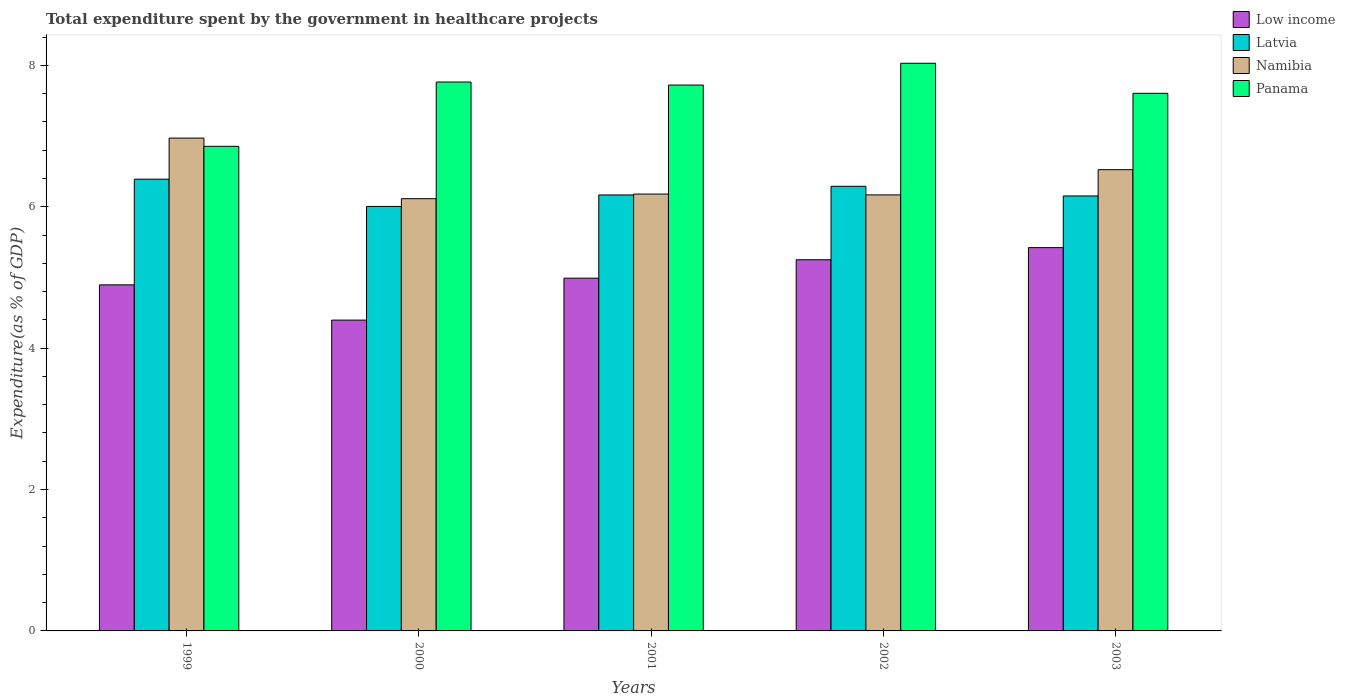How many different coloured bars are there?
Ensure brevity in your answer.  4. How many groups of bars are there?
Give a very brief answer. 5. Are the number of bars per tick equal to the number of legend labels?
Your answer should be very brief. Yes. Are the number of bars on each tick of the X-axis equal?
Your response must be concise. Yes. How many bars are there on the 2nd tick from the right?
Offer a terse response. 4. In how many cases, is the number of bars for a given year not equal to the number of legend labels?
Your answer should be compact. 0. What is the total expenditure spent by the government in healthcare projects in Namibia in 1999?
Provide a short and direct response. 6.97. Across all years, what is the maximum total expenditure spent by the government in healthcare projects in Low income?
Your answer should be compact. 5.42. Across all years, what is the minimum total expenditure spent by the government in healthcare projects in Low income?
Offer a terse response. 4.4. In which year was the total expenditure spent by the government in healthcare projects in Namibia minimum?
Offer a very short reply. 2000. What is the total total expenditure spent by the government in healthcare projects in Panama in the graph?
Provide a short and direct response. 37.97. What is the difference between the total expenditure spent by the government in healthcare projects in Low income in 1999 and that in 2000?
Give a very brief answer. 0.5. What is the difference between the total expenditure spent by the government in healthcare projects in Panama in 2003 and the total expenditure spent by the government in healthcare projects in Namibia in 2002?
Ensure brevity in your answer.  1.44. What is the average total expenditure spent by the government in healthcare projects in Latvia per year?
Provide a succinct answer. 6.2. In the year 2002, what is the difference between the total expenditure spent by the government in healthcare projects in Panama and total expenditure spent by the government in healthcare projects in Namibia?
Make the answer very short. 1.86. What is the ratio of the total expenditure spent by the government in healthcare projects in Namibia in 2000 to that in 2001?
Your answer should be very brief. 0.99. What is the difference between the highest and the second highest total expenditure spent by the government in healthcare projects in Namibia?
Your answer should be compact. 0.45. What is the difference between the highest and the lowest total expenditure spent by the government in healthcare projects in Low income?
Provide a succinct answer. 1.02. In how many years, is the total expenditure spent by the government in healthcare projects in Namibia greater than the average total expenditure spent by the government in healthcare projects in Namibia taken over all years?
Your response must be concise. 2. Is the sum of the total expenditure spent by the government in healthcare projects in Panama in 2000 and 2001 greater than the maximum total expenditure spent by the government in healthcare projects in Namibia across all years?
Offer a terse response. Yes. Is it the case that in every year, the sum of the total expenditure spent by the government in healthcare projects in Panama and total expenditure spent by the government in healthcare projects in Latvia is greater than the sum of total expenditure spent by the government in healthcare projects in Low income and total expenditure spent by the government in healthcare projects in Namibia?
Offer a terse response. No. What does the 2nd bar from the left in 2000 represents?
Keep it short and to the point. Latvia. What does the 3rd bar from the right in 2003 represents?
Keep it short and to the point. Latvia. How many bars are there?
Make the answer very short. 20. How many years are there in the graph?
Ensure brevity in your answer.  5. What is the difference between two consecutive major ticks on the Y-axis?
Your response must be concise. 2. Does the graph contain any zero values?
Your answer should be compact. No. How many legend labels are there?
Ensure brevity in your answer.  4. How are the legend labels stacked?
Keep it short and to the point. Vertical. What is the title of the graph?
Provide a short and direct response. Total expenditure spent by the government in healthcare projects. Does "Tonga" appear as one of the legend labels in the graph?
Provide a succinct answer. No. What is the label or title of the Y-axis?
Provide a short and direct response. Expenditure(as % of GDP). What is the Expenditure(as % of GDP) of Low income in 1999?
Ensure brevity in your answer.  4.89. What is the Expenditure(as % of GDP) in Latvia in 1999?
Provide a short and direct response. 6.39. What is the Expenditure(as % of GDP) in Namibia in 1999?
Your answer should be very brief. 6.97. What is the Expenditure(as % of GDP) of Panama in 1999?
Your response must be concise. 6.85. What is the Expenditure(as % of GDP) of Low income in 2000?
Keep it short and to the point. 4.4. What is the Expenditure(as % of GDP) of Latvia in 2000?
Provide a succinct answer. 6. What is the Expenditure(as % of GDP) of Namibia in 2000?
Make the answer very short. 6.11. What is the Expenditure(as % of GDP) in Panama in 2000?
Make the answer very short. 7.76. What is the Expenditure(as % of GDP) in Low income in 2001?
Provide a short and direct response. 4.99. What is the Expenditure(as % of GDP) in Latvia in 2001?
Offer a terse response. 6.17. What is the Expenditure(as % of GDP) in Namibia in 2001?
Your answer should be compact. 6.18. What is the Expenditure(as % of GDP) in Panama in 2001?
Provide a short and direct response. 7.72. What is the Expenditure(as % of GDP) of Low income in 2002?
Ensure brevity in your answer.  5.25. What is the Expenditure(as % of GDP) in Latvia in 2002?
Keep it short and to the point. 6.29. What is the Expenditure(as % of GDP) of Namibia in 2002?
Provide a short and direct response. 6.17. What is the Expenditure(as % of GDP) in Panama in 2002?
Provide a succinct answer. 8.03. What is the Expenditure(as % of GDP) of Low income in 2003?
Offer a very short reply. 5.42. What is the Expenditure(as % of GDP) in Latvia in 2003?
Provide a short and direct response. 6.15. What is the Expenditure(as % of GDP) in Namibia in 2003?
Give a very brief answer. 6.52. What is the Expenditure(as % of GDP) of Panama in 2003?
Give a very brief answer. 7.6. Across all years, what is the maximum Expenditure(as % of GDP) in Low income?
Give a very brief answer. 5.42. Across all years, what is the maximum Expenditure(as % of GDP) of Latvia?
Your answer should be compact. 6.39. Across all years, what is the maximum Expenditure(as % of GDP) of Namibia?
Ensure brevity in your answer.  6.97. Across all years, what is the maximum Expenditure(as % of GDP) of Panama?
Offer a very short reply. 8.03. Across all years, what is the minimum Expenditure(as % of GDP) of Low income?
Keep it short and to the point. 4.4. Across all years, what is the minimum Expenditure(as % of GDP) of Latvia?
Ensure brevity in your answer.  6. Across all years, what is the minimum Expenditure(as % of GDP) of Namibia?
Make the answer very short. 6.11. Across all years, what is the minimum Expenditure(as % of GDP) of Panama?
Your answer should be very brief. 6.85. What is the total Expenditure(as % of GDP) in Low income in the graph?
Provide a short and direct response. 24.95. What is the total Expenditure(as % of GDP) of Latvia in the graph?
Give a very brief answer. 31. What is the total Expenditure(as % of GDP) in Namibia in the graph?
Offer a terse response. 31.96. What is the total Expenditure(as % of GDP) of Panama in the graph?
Your answer should be compact. 37.97. What is the difference between the Expenditure(as % of GDP) in Low income in 1999 and that in 2000?
Offer a terse response. 0.5. What is the difference between the Expenditure(as % of GDP) in Latvia in 1999 and that in 2000?
Offer a very short reply. 0.39. What is the difference between the Expenditure(as % of GDP) of Namibia in 1999 and that in 2000?
Your answer should be very brief. 0.86. What is the difference between the Expenditure(as % of GDP) of Panama in 1999 and that in 2000?
Your answer should be very brief. -0.91. What is the difference between the Expenditure(as % of GDP) in Low income in 1999 and that in 2001?
Keep it short and to the point. -0.09. What is the difference between the Expenditure(as % of GDP) in Latvia in 1999 and that in 2001?
Offer a very short reply. 0.22. What is the difference between the Expenditure(as % of GDP) in Namibia in 1999 and that in 2001?
Ensure brevity in your answer.  0.79. What is the difference between the Expenditure(as % of GDP) in Panama in 1999 and that in 2001?
Make the answer very short. -0.87. What is the difference between the Expenditure(as % of GDP) of Low income in 1999 and that in 2002?
Your answer should be very brief. -0.36. What is the difference between the Expenditure(as % of GDP) of Latvia in 1999 and that in 2002?
Your answer should be compact. 0.1. What is the difference between the Expenditure(as % of GDP) of Namibia in 1999 and that in 2002?
Provide a short and direct response. 0.8. What is the difference between the Expenditure(as % of GDP) of Panama in 1999 and that in 2002?
Offer a terse response. -1.17. What is the difference between the Expenditure(as % of GDP) in Low income in 1999 and that in 2003?
Offer a very short reply. -0.53. What is the difference between the Expenditure(as % of GDP) of Latvia in 1999 and that in 2003?
Your response must be concise. 0.24. What is the difference between the Expenditure(as % of GDP) in Namibia in 1999 and that in 2003?
Make the answer very short. 0.45. What is the difference between the Expenditure(as % of GDP) of Panama in 1999 and that in 2003?
Keep it short and to the point. -0.75. What is the difference between the Expenditure(as % of GDP) of Low income in 2000 and that in 2001?
Your answer should be very brief. -0.59. What is the difference between the Expenditure(as % of GDP) of Latvia in 2000 and that in 2001?
Offer a terse response. -0.16. What is the difference between the Expenditure(as % of GDP) of Namibia in 2000 and that in 2001?
Make the answer very short. -0.07. What is the difference between the Expenditure(as % of GDP) in Panama in 2000 and that in 2001?
Give a very brief answer. 0.04. What is the difference between the Expenditure(as % of GDP) of Low income in 2000 and that in 2002?
Your answer should be very brief. -0.85. What is the difference between the Expenditure(as % of GDP) in Latvia in 2000 and that in 2002?
Provide a succinct answer. -0.28. What is the difference between the Expenditure(as % of GDP) of Namibia in 2000 and that in 2002?
Your response must be concise. -0.05. What is the difference between the Expenditure(as % of GDP) in Panama in 2000 and that in 2002?
Your answer should be very brief. -0.27. What is the difference between the Expenditure(as % of GDP) of Low income in 2000 and that in 2003?
Offer a terse response. -1.02. What is the difference between the Expenditure(as % of GDP) of Latvia in 2000 and that in 2003?
Ensure brevity in your answer.  -0.15. What is the difference between the Expenditure(as % of GDP) of Namibia in 2000 and that in 2003?
Your answer should be compact. -0.41. What is the difference between the Expenditure(as % of GDP) in Panama in 2000 and that in 2003?
Provide a succinct answer. 0.16. What is the difference between the Expenditure(as % of GDP) of Low income in 2001 and that in 2002?
Keep it short and to the point. -0.26. What is the difference between the Expenditure(as % of GDP) of Latvia in 2001 and that in 2002?
Ensure brevity in your answer.  -0.12. What is the difference between the Expenditure(as % of GDP) in Namibia in 2001 and that in 2002?
Give a very brief answer. 0.01. What is the difference between the Expenditure(as % of GDP) in Panama in 2001 and that in 2002?
Keep it short and to the point. -0.31. What is the difference between the Expenditure(as % of GDP) of Low income in 2001 and that in 2003?
Make the answer very short. -0.43. What is the difference between the Expenditure(as % of GDP) in Latvia in 2001 and that in 2003?
Your answer should be compact. 0.01. What is the difference between the Expenditure(as % of GDP) in Namibia in 2001 and that in 2003?
Your response must be concise. -0.34. What is the difference between the Expenditure(as % of GDP) in Panama in 2001 and that in 2003?
Ensure brevity in your answer.  0.12. What is the difference between the Expenditure(as % of GDP) in Low income in 2002 and that in 2003?
Provide a succinct answer. -0.17. What is the difference between the Expenditure(as % of GDP) of Latvia in 2002 and that in 2003?
Ensure brevity in your answer.  0.14. What is the difference between the Expenditure(as % of GDP) in Namibia in 2002 and that in 2003?
Provide a succinct answer. -0.36. What is the difference between the Expenditure(as % of GDP) of Panama in 2002 and that in 2003?
Ensure brevity in your answer.  0.42. What is the difference between the Expenditure(as % of GDP) of Low income in 1999 and the Expenditure(as % of GDP) of Latvia in 2000?
Offer a terse response. -1.11. What is the difference between the Expenditure(as % of GDP) in Low income in 1999 and the Expenditure(as % of GDP) in Namibia in 2000?
Make the answer very short. -1.22. What is the difference between the Expenditure(as % of GDP) of Low income in 1999 and the Expenditure(as % of GDP) of Panama in 2000?
Your answer should be very brief. -2.87. What is the difference between the Expenditure(as % of GDP) of Latvia in 1999 and the Expenditure(as % of GDP) of Namibia in 2000?
Offer a very short reply. 0.28. What is the difference between the Expenditure(as % of GDP) in Latvia in 1999 and the Expenditure(as % of GDP) in Panama in 2000?
Ensure brevity in your answer.  -1.37. What is the difference between the Expenditure(as % of GDP) in Namibia in 1999 and the Expenditure(as % of GDP) in Panama in 2000?
Provide a short and direct response. -0.79. What is the difference between the Expenditure(as % of GDP) of Low income in 1999 and the Expenditure(as % of GDP) of Latvia in 2001?
Make the answer very short. -1.27. What is the difference between the Expenditure(as % of GDP) in Low income in 1999 and the Expenditure(as % of GDP) in Namibia in 2001?
Your answer should be very brief. -1.28. What is the difference between the Expenditure(as % of GDP) of Low income in 1999 and the Expenditure(as % of GDP) of Panama in 2001?
Keep it short and to the point. -2.83. What is the difference between the Expenditure(as % of GDP) in Latvia in 1999 and the Expenditure(as % of GDP) in Namibia in 2001?
Ensure brevity in your answer.  0.21. What is the difference between the Expenditure(as % of GDP) in Latvia in 1999 and the Expenditure(as % of GDP) in Panama in 2001?
Give a very brief answer. -1.33. What is the difference between the Expenditure(as % of GDP) of Namibia in 1999 and the Expenditure(as % of GDP) of Panama in 2001?
Make the answer very short. -0.75. What is the difference between the Expenditure(as % of GDP) in Low income in 1999 and the Expenditure(as % of GDP) in Latvia in 2002?
Provide a short and direct response. -1.39. What is the difference between the Expenditure(as % of GDP) in Low income in 1999 and the Expenditure(as % of GDP) in Namibia in 2002?
Offer a terse response. -1.27. What is the difference between the Expenditure(as % of GDP) of Low income in 1999 and the Expenditure(as % of GDP) of Panama in 2002?
Ensure brevity in your answer.  -3.13. What is the difference between the Expenditure(as % of GDP) of Latvia in 1999 and the Expenditure(as % of GDP) of Namibia in 2002?
Offer a very short reply. 0.22. What is the difference between the Expenditure(as % of GDP) of Latvia in 1999 and the Expenditure(as % of GDP) of Panama in 2002?
Ensure brevity in your answer.  -1.64. What is the difference between the Expenditure(as % of GDP) of Namibia in 1999 and the Expenditure(as % of GDP) of Panama in 2002?
Make the answer very short. -1.06. What is the difference between the Expenditure(as % of GDP) in Low income in 1999 and the Expenditure(as % of GDP) in Latvia in 2003?
Give a very brief answer. -1.26. What is the difference between the Expenditure(as % of GDP) in Low income in 1999 and the Expenditure(as % of GDP) in Namibia in 2003?
Your answer should be compact. -1.63. What is the difference between the Expenditure(as % of GDP) in Low income in 1999 and the Expenditure(as % of GDP) in Panama in 2003?
Your response must be concise. -2.71. What is the difference between the Expenditure(as % of GDP) in Latvia in 1999 and the Expenditure(as % of GDP) in Namibia in 2003?
Offer a terse response. -0.13. What is the difference between the Expenditure(as % of GDP) in Latvia in 1999 and the Expenditure(as % of GDP) in Panama in 2003?
Provide a succinct answer. -1.21. What is the difference between the Expenditure(as % of GDP) of Namibia in 1999 and the Expenditure(as % of GDP) of Panama in 2003?
Give a very brief answer. -0.63. What is the difference between the Expenditure(as % of GDP) in Low income in 2000 and the Expenditure(as % of GDP) in Latvia in 2001?
Provide a short and direct response. -1.77. What is the difference between the Expenditure(as % of GDP) in Low income in 2000 and the Expenditure(as % of GDP) in Namibia in 2001?
Offer a very short reply. -1.78. What is the difference between the Expenditure(as % of GDP) in Low income in 2000 and the Expenditure(as % of GDP) in Panama in 2001?
Make the answer very short. -3.32. What is the difference between the Expenditure(as % of GDP) of Latvia in 2000 and the Expenditure(as % of GDP) of Namibia in 2001?
Your answer should be very brief. -0.17. What is the difference between the Expenditure(as % of GDP) in Latvia in 2000 and the Expenditure(as % of GDP) in Panama in 2001?
Your answer should be compact. -1.72. What is the difference between the Expenditure(as % of GDP) of Namibia in 2000 and the Expenditure(as % of GDP) of Panama in 2001?
Make the answer very short. -1.61. What is the difference between the Expenditure(as % of GDP) of Low income in 2000 and the Expenditure(as % of GDP) of Latvia in 2002?
Your answer should be compact. -1.89. What is the difference between the Expenditure(as % of GDP) of Low income in 2000 and the Expenditure(as % of GDP) of Namibia in 2002?
Your response must be concise. -1.77. What is the difference between the Expenditure(as % of GDP) in Low income in 2000 and the Expenditure(as % of GDP) in Panama in 2002?
Offer a terse response. -3.63. What is the difference between the Expenditure(as % of GDP) in Latvia in 2000 and the Expenditure(as % of GDP) in Namibia in 2002?
Your response must be concise. -0.16. What is the difference between the Expenditure(as % of GDP) in Latvia in 2000 and the Expenditure(as % of GDP) in Panama in 2002?
Your answer should be compact. -2.03. What is the difference between the Expenditure(as % of GDP) of Namibia in 2000 and the Expenditure(as % of GDP) of Panama in 2002?
Your answer should be compact. -1.92. What is the difference between the Expenditure(as % of GDP) in Low income in 2000 and the Expenditure(as % of GDP) in Latvia in 2003?
Ensure brevity in your answer.  -1.76. What is the difference between the Expenditure(as % of GDP) of Low income in 2000 and the Expenditure(as % of GDP) of Namibia in 2003?
Provide a succinct answer. -2.13. What is the difference between the Expenditure(as % of GDP) in Low income in 2000 and the Expenditure(as % of GDP) in Panama in 2003?
Give a very brief answer. -3.21. What is the difference between the Expenditure(as % of GDP) in Latvia in 2000 and the Expenditure(as % of GDP) in Namibia in 2003?
Offer a terse response. -0.52. What is the difference between the Expenditure(as % of GDP) in Latvia in 2000 and the Expenditure(as % of GDP) in Panama in 2003?
Offer a terse response. -1.6. What is the difference between the Expenditure(as % of GDP) in Namibia in 2000 and the Expenditure(as % of GDP) in Panama in 2003?
Provide a succinct answer. -1.49. What is the difference between the Expenditure(as % of GDP) of Low income in 2001 and the Expenditure(as % of GDP) of Latvia in 2002?
Your answer should be very brief. -1.3. What is the difference between the Expenditure(as % of GDP) of Low income in 2001 and the Expenditure(as % of GDP) of Namibia in 2002?
Offer a very short reply. -1.18. What is the difference between the Expenditure(as % of GDP) of Low income in 2001 and the Expenditure(as % of GDP) of Panama in 2002?
Offer a terse response. -3.04. What is the difference between the Expenditure(as % of GDP) of Latvia in 2001 and the Expenditure(as % of GDP) of Namibia in 2002?
Provide a succinct answer. -0. What is the difference between the Expenditure(as % of GDP) in Latvia in 2001 and the Expenditure(as % of GDP) in Panama in 2002?
Provide a succinct answer. -1.86. What is the difference between the Expenditure(as % of GDP) in Namibia in 2001 and the Expenditure(as % of GDP) in Panama in 2002?
Provide a succinct answer. -1.85. What is the difference between the Expenditure(as % of GDP) in Low income in 2001 and the Expenditure(as % of GDP) in Latvia in 2003?
Ensure brevity in your answer.  -1.16. What is the difference between the Expenditure(as % of GDP) in Low income in 2001 and the Expenditure(as % of GDP) in Namibia in 2003?
Keep it short and to the point. -1.53. What is the difference between the Expenditure(as % of GDP) of Low income in 2001 and the Expenditure(as % of GDP) of Panama in 2003?
Keep it short and to the point. -2.61. What is the difference between the Expenditure(as % of GDP) of Latvia in 2001 and the Expenditure(as % of GDP) of Namibia in 2003?
Offer a terse response. -0.36. What is the difference between the Expenditure(as % of GDP) in Latvia in 2001 and the Expenditure(as % of GDP) in Panama in 2003?
Ensure brevity in your answer.  -1.44. What is the difference between the Expenditure(as % of GDP) in Namibia in 2001 and the Expenditure(as % of GDP) in Panama in 2003?
Your answer should be very brief. -1.43. What is the difference between the Expenditure(as % of GDP) of Low income in 2002 and the Expenditure(as % of GDP) of Latvia in 2003?
Give a very brief answer. -0.9. What is the difference between the Expenditure(as % of GDP) in Low income in 2002 and the Expenditure(as % of GDP) in Namibia in 2003?
Your answer should be compact. -1.27. What is the difference between the Expenditure(as % of GDP) in Low income in 2002 and the Expenditure(as % of GDP) in Panama in 2003?
Offer a very short reply. -2.35. What is the difference between the Expenditure(as % of GDP) of Latvia in 2002 and the Expenditure(as % of GDP) of Namibia in 2003?
Your answer should be very brief. -0.23. What is the difference between the Expenditure(as % of GDP) in Latvia in 2002 and the Expenditure(as % of GDP) in Panama in 2003?
Provide a short and direct response. -1.32. What is the difference between the Expenditure(as % of GDP) in Namibia in 2002 and the Expenditure(as % of GDP) in Panama in 2003?
Give a very brief answer. -1.44. What is the average Expenditure(as % of GDP) of Low income per year?
Offer a terse response. 4.99. What is the average Expenditure(as % of GDP) of Latvia per year?
Your response must be concise. 6.2. What is the average Expenditure(as % of GDP) of Namibia per year?
Provide a short and direct response. 6.39. What is the average Expenditure(as % of GDP) in Panama per year?
Provide a succinct answer. 7.59. In the year 1999, what is the difference between the Expenditure(as % of GDP) of Low income and Expenditure(as % of GDP) of Latvia?
Your response must be concise. -1.5. In the year 1999, what is the difference between the Expenditure(as % of GDP) of Low income and Expenditure(as % of GDP) of Namibia?
Provide a succinct answer. -2.08. In the year 1999, what is the difference between the Expenditure(as % of GDP) of Low income and Expenditure(as % of GDP) of Panama?
Keep it short and to the point. -1.96. In the year 1999, what is the difference between the Expenditure(as % of GDP) of Latvia and Expenditure(as % of GDP) of Namibia?
Give a very brief answer. -0.58. In the year 1999, what is the difference between the Expenditure(as % of GDP) in Latvia and Expenditure(as % of GDP) in Panama?
Offer a very short reply. -0.46. In the year 1999, what is the difference between the Expenditure(as % of GDP) in Namibia and Expenditure(as % of GDP) in Panama?
Your response must be concise. 0.12. In the year 2000, what is the difference between the Expenditure(as % of GDP) in Low income and Expenditure(as % of GDP) in Latvia?
Ensure brevity in your answer.  -1.61. In the year 2000, what is the difference between the Expenditure(as % of GDP) in Low income and Expenditure(as % of GDP) in Namibia?
Ensure brevity in your answer.  -1.72. In the year 2000, what is the difference between the Expenditure(as % of GDP) of Low income and Expenditure(as % of GDP) of Panama?
Keep it short and to the point. -3.37. In the year 2000, what is the difference between the Expenditure(as % of GDP) of Latvia and Expenditure(as % of GDP) of Namibia?
Ensure brevity in your answer.  -0.11. In the year 2000, what is the difference between the Expenditure(as % of GDP) of Latvia and Expenditure(as % of GDP) of Panama?
Give a very brief answer. -1.76. In the year 2000, what is the difference between the Expenditure(as % of GDP) of Namibia and Expenditure(as % of GDP) of Panama?
Provide a short and direct response. -1.65. In the year 2001, what is the difference between the Expenditure(as % of GDP) in Low income and Expenditure(as % of GDP) in Latvia?
Your response must be concise. -1.18. In the year 2001, what is the difference between the Expenditure(as % of GDP) of Low income and Expenditure(as % of GDP) of Namibia?
Give a very brief answer. -1.19. In the year 2001, what is the difference between the Expenditure(as % of GDP) of Low income and Expenditure(as % of GDP) of Panama?
Provide a succinct answer. -2.73. In the year 2001, what is the difference between the Expenditure(as % of GDP) in Latvia and Expenditure(as % of GDP) in Namibia?
Provide a short and direct response. -0.01. In the year 2001, what is the difference between the Expenditure(as % of GDP) in Latvia and Expenditure(as % of GDP) in Panama?
Make the answer very short. -1.55. In the year 2001, what is the difference between the Expenditure(as % of GDP) of Namibia and Expenditure(as % of GDP) of Panama?
Give a very brief answer. -1.54. In the year 2002, what is the difference between the Expenditure(as % of GDP) of Low income and Expenditure(as % of GDP) of Latvia?
Your answer should be compact. -1.04. In the year 2002, what is the difference between the Expenditure(as % of GDP) in Low income and Expenditure(as % of GDP) in Namibia?
Your response must be concise. -0.92. In the year 2002, what is the difference between the Expenditure(as % of GDP) in Low income and Expenditure(as % of GDP) in Panama?
Offer a terse response. -2.78. In the year 2002, what is the difference between the Expenditure(as % of GDP) in Latvia and Expenditure(as % of GDP) in Namibia?
Your response must be concise. 0.12. In the year 2002, what is the difference between the Expenditure(as % of GDP) of Latvia and Expenditure(as % of GDP) of Panama?
Your answer should be very brief. -1.74. In the year 2002, what is the difference between the Expenditure(as % of GDP) of Namibia and Expenditure(as % of GDP) of Panama?
Give a very brief answer. -1.86. In the year 2003, what is the difference between the Expenditure(as % of GDP) of Low income and Expenditure(as % of GDP) of Latvia?
Offer a terse response. -0.73. In the year 2003, what is the difference between the Expenditure(as % of GDP) of Low income and Expenditure(as % of GDP) of Namibia?
Your answer should be very brief. -1.1. In the year 2003, what is the difference between the Expenditure(as % of GDP) of Low income and Expenditure(as % of GDP) of Panama?
Provide a succinct answer. -2.18. In the year 2003, what is the difference between the Expenditure(as % of GDP) in Latvia and Expenditure(as % of GDP) in Namibia?
Your response must be concise. -0.37. In the year 2003, what is the difference between the Expenditure(as % of GDP) in Latvia and Expenditure(as % of GDP) in Panama?
Provide a short and direct response. -1.45. In the year 2003, what is the difference between the Expenditure(as % of GDP) of Namibia and Expenditure(as % of GDP) of Panama?
Ensure brevity in your answer.  -1.08. What is the ratio of the Expenditure(as % of GDP) in Low income in 1999 to that in 2000?
Provide a short and direct response. 1.11. What is the ratio of the Expenditure(as % of GDP) in Latvia in 1999 to that in 2000?
Your answer should be very brief. 1.06. What is the ratio of the Expenditure(as % of GDP) in Namibia in 1999 to that in 2000?
Your answer should be very brief. 1.14. What is the ratio of the Expenditure(as % of GDP) in Panama in 1999 to that in 2000?
Ensure brevity in your answer.  0.88. What is the ratio of the Expenditure(as % of GDP) in Latvia in 1999 to that in 2001?
Provide a succinct answer. 1.04. What is the ratio of the Expenditure(as % of GDP) of Namibia in 1999 to that in 2001?
Make the answer very short. 1.13. What is the ratio of the Expenditure(as % of GDP) in Panama in 1999 to that in 2001?
Your response must be concise. 0.89. What is the ratio of the Expenditure(as % of GDP) of Low income in 1999 to that in 2002?
Provide a short and direct response. 0.93. What is the ratio of the Expenditure(as % of GDP) of Latvia in 1999 to that in 2002?
Provide a succinct answer. 1.02. What is the ratio of the Expenditure(as % of GDP) of Namibia in 1999 to that in 2002?
Make the answer very short. 1.13. What is the ratio of the Expenditure(as % of GDP) of Panama in 1999 to that in 2002?
Your response must be concise. 0.85. What is the ratio of the Expenditure(as % of GDP) of Low income in 1999 to that in 2003?
Your answer should be compact. 0.9. What is the ratio of the Expenditure(as % of GDP) in Latvia in 1999 to that in 2003?
Offer a terse response. 1.04. What is the ratio of the Expenditure(as % of GDP) in Namibia in 1999 to that in 2003?
Provide a succinct answer. 1.07. What is the ratio of the Expenditure(as % of GDP) in Panama in 1999 to that in 2003?
Provide a succinct answer. 0.9. What is the ratio of the Expenditure(as % of GDP) of Low income in 2000 to that in 2001?
Provide a succinct answer. 0.88. What is the ratio of the Expenditure(as % of GDP) in Latvia in 2000 to that in 2001?
Give a very brief answer. 0.97. What is the ratio of the Expenditure(as % of GDP) in Panama in 2000 to that in 2001?
Provide a short and direct response. 1.01. What is the ratio of the Expenditure(as % of GDP) in Low income in 2000 to that in 2002?
Your answer should be compact. 0.84. What is the ratio of the Expenditure(as % of GDP) of Latvia in 2000 to that in 2002?
Offer a terse response. 0.95. What is the ratio of the Expenditure(as % of GDP) of Panama in 2000 to that in 2002?
Offer a terse response. 0.97. What is the ratio of the Expenditure(as % of GDP) of Low income in 2000 to that in 2003?
Make the answer very short. 0.81. What is the ratio of the Expenditure(as % of GDP) in Latvia in 2000 to that in 2003?
Your answer should be very brief. 0.98. What is the ratio of the Expenditure(as % of GDP) in Namibia in 2000 to that in 2003?
Offer a very short reply. 0.94. What is the ratio of the Expenditure(as % of GDP) of Panama in 2000 to that in 2003?
Offer a terse response. 1.02. What is the ratio of the Expenditure(as % of GDP) in Low income in 2001 to that in 2002?
Ensure brevity in your answer.  0.95. What is the ratio of the Expenditure(as % of GDP) in Latvia in 2001 to that in 2002?
Your answer should be compact. 0.98. What is the ratio of the Expenditure(as % of GDP) in Panama in 2001 to that in 2002?
Your answer should be very brief. 0.96. What is the ratio of the Expenditure(as % of GDP) of Low income in 2001 to that in 2003?
Your answer should be compact. 0.92. What is the ratio of the Expenditure(as % of GDP) in Namibia in 2001 to that in 2003?
Keep it short and to the point. 0.95. What is the ratio of the Expenditure(as % of GDP) of Panama in 2001 to that in 2003?
Offer a very short reply. 1.02. What is the ratio of the Expenditure(as % of GDP) of Low income in 2002 to that in 2003?
Provide a short and direct response. 0.97. What is the ratio of the Expenditure(as % of GDP) of Latvia in 2002 to that in 2003?
Ensure brevity in your answer.  1.02. What is the ratio of the Expenditure(as % of GDP) of Namibia in 2002 to that in 2003?
Offer a very short reply. 0.95. What is the ratio of the Expenditure(as % of GDP) of Panama in 2002 to that in 2003?
Provide a short and direct response. 1.06. What is the difference between the highest and the second highest Expenditure(as % of GDP) of Low income?
Offer a very short reply. 0.17. What is the difference between the highest and the second highest Expenditure(as % of GDP) of Latvia?
Offer a very short reply. 0.1. What is the difference between the highest and the second highest Expenditure(as % of GDP) in Namibia?
Ensure brevity in your answer.  0.45. What is the difference between the highest and the second highest Expenditure(as % of GDP) of Panama?
Make the answer very short. 0.27. What is the difference between the highest and the lowest Expenditure(as % of GDP) in Latvia?
Your response must be concise. 0.39. What is the difference between the highest and the lowest Expenditure(as % of GDP) in Namibia?
Keep it short and to the point. 0.86. What is the difference between the highest and the lowest Expenditure(as % of GDP) in Panama?
Your answer should be compact. 1.17. 